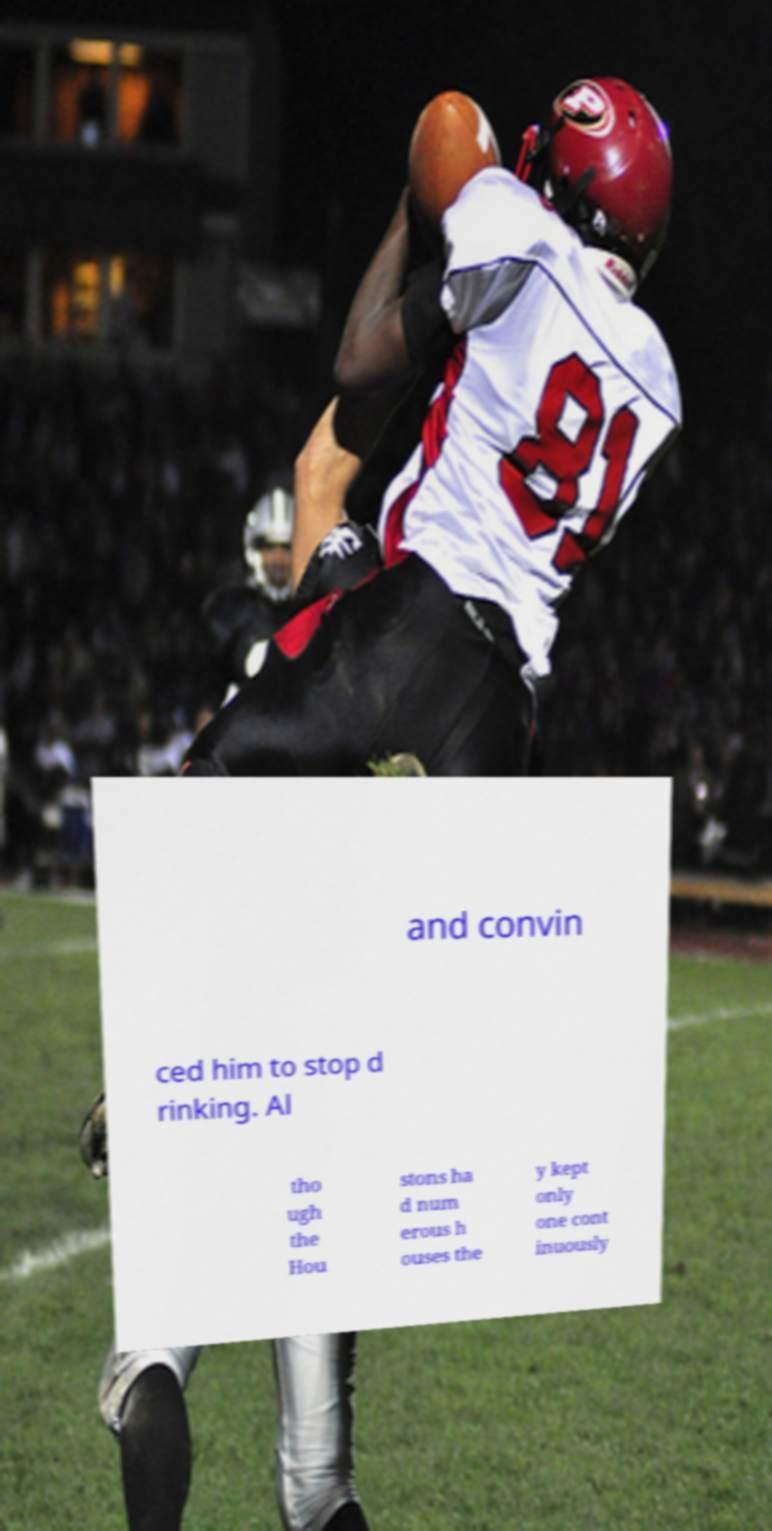There's text embedded in this image that I need extracted. Can you transcribe it verbatim? and convin ced him to stop d rinking. Al tho ugh the Hou stons ha d num erous h ouses the y kept only one cont inuously 